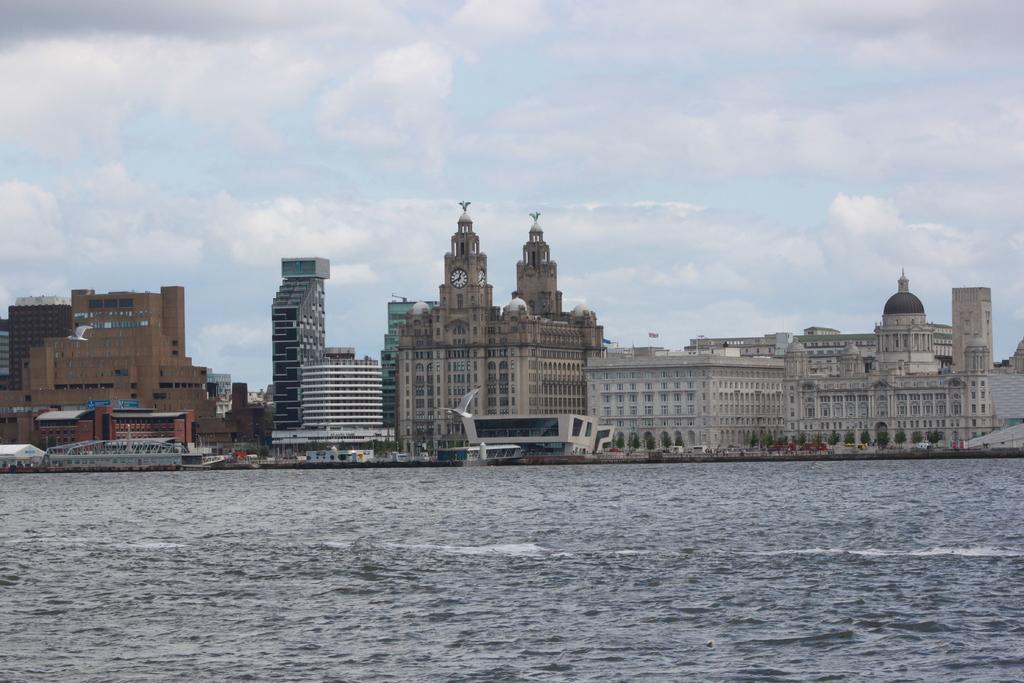How would you summarize this image in a sentence or two? This image is taken outdoors. At the top of the image there is the sky with clouds. At the bottom of the image there is the sea. In the middle of the image there are many buildings with walls, windows, doors, pillars, balconies and roofs. There are two towers with clocks. There are a few boats on the sea. There are a few trees. 